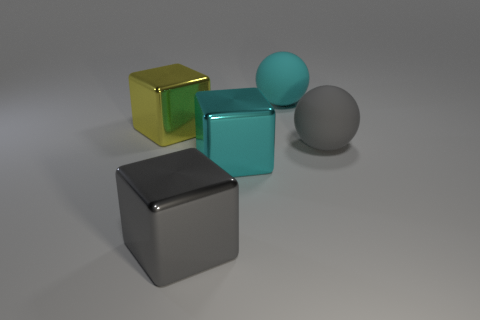There is a sphere in front of the cyan rubber sphere; what color is it?
Provide a succinct answer. Gray. Is there a gray metallic object that is on the right side of the large gray shiny thing that is on the left side of the gray rubber thing?
Make the answer very short. No. Is there a cyan sphere that has the same material as the big gray block?
Offer a very short reply. No. What number of cyan balls are there?
Your answer should be compact. 1. What is the material of the big cyan thing in front of the big ball that is behind the large gray rubber thing?
Your response must be concise. Metal. The object that is the same material as the gray ball is what color?
Ensure brevity in your answer.  Cyan. Do the cyan metallic block that is in front of the cyan sphere and the metallic block on the left side of the large gray cube have the same size?
Your response must be concise. Yes. How many cubes are rubber objects or cyan objects?
Make the answer very short. 1. Is the gray object behind the big cyan block made of the same material as the yellow block?
Make the answer very short. No. How many other objects are there of the same size as the gray block?
Offer a terse response. 4. 